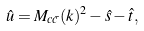Convert formula to latex. <formula><loc_0><loc_0><loc_500><loc_500>\hat { u } = M _ { c \bar { c } } ( k ) ^ { 2 } - \hat { s } - \hat { t } ,</formula> 